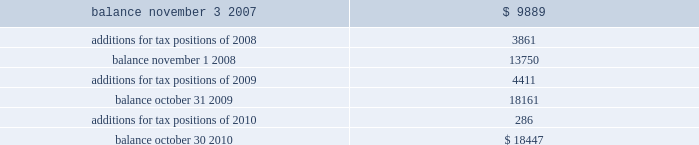Of global business , there are many transactions and calculations where the ultimate tax outcome is uncertain .
Some of these uncertainties arise as a consequence of cost reimbursement arrangements among related entities .
Although the company believes its estimates are reasonable , no assurance can be given that the final tax outcome of these matters will not be different than that which is reflected in the historical income tax provisions and accruals .
Such differences could have a material impact on the company 2019s income tax provision and operating results in the period in which such determination is made .
On november 4 , 2007 ( the first day of its 2008 fiscal year ) , the company adopted new accounting principles on accounting for uncertain tax positions .
These principles require companies to determine whether it is 201cmore likely than not 201d that a tax position will be sustained upon examination by the appropriate taxing authorities before any benefit can be recorded in the financial statements .
An uncertain income tax position will not be recognized if it has less than a 50% ( 50 % ) likelihood of being sustained .
There were no changes to the company 2019s liabilities for uncertain tax positions as a result of the adoption of these provisions .
As of october 30 , 2010 and october 31 , 2009 , the company had a liability of $ 18.4 million and $ 18.2 million , respectively , for gross unrealized tax benefits , all of which , if settled in the company 2019s favor , would lower the company 2019s effective tax rate in the period recorded .
In addition , as of october 30 , 2010 and october 31 , 2009 , the company had a liability of approximately $ 9.8 million and $ 8.0 million , respectively , for interest and penalties .
The total liability as of october 30 , 2010 and october 31 , 2009 of $ 28.3 million and $ 26.2 million , respectively , for uncertain tax positions is classified as non-current , and is included in other non-current liabilities , because the company believes that the ultimate payment or settlement of these liabilities will not occur within the next twelve months .
Prior to the adoption of these provisions , these amounts were included in current income tax payable .
The company includes interest and penalties related to unrecognized tax benefits within the provision for taxes in the condensed consolidated statements of income , and as a result , no change in classification was made upon adopting these provisions .
The condensed consolidated statements of income for fiscal years 2010 , 2009 and 2008 include $ 1.8 million , $ 1.7 million and $ 1.3 million , respectively , of interest and penalties related to these uncertain tax positions .
Due to the complexity associated with its tax uncertainties , the company cannot make a reasonably reliable estimate as to the period in which it expects to settle the liabilities associated with these uncertain tax positions .
The table summarizes the changes in the total amounts of uncertain tax positions for fiscal 2008 through fiscal 2010. .
Fiscal years 2004 and 2005 irs examination during the fourth quarter of fiscal 2007 , the irs completed its field examination of the company 2019s fiscal years 2004 and 2005 .
On january 2 , 2008 , the irs issued its report for fiscal 2004 and 2005 , which included proposed adjustments related to these two fiscal years .
The company has recorded taxes and penalties related to certain of these proposed adjustments .
There are four items with an additional potential total tax liability of $ 46 million .
The company has concluded , based on discussions with its tax advisors , that these four items are not likely to result in any additional tax liability .
Therefore , the company has not recorded any additional tax liability for these items and is appealing these proposed adjustments through the normal processes for the resolution of differences between the irs and taxpayers .
The company 2019s initial meetings with the appellate division of the irs were held during fiscal analog devices , inc .
Notes to consolidated financial statements 2014 ( continued ) .
What was the percentage increase of income for the fiscal years of 2008 to 2010? 
Rationale: to find the percentage increase of income for the years of 2008 to 2010 one must subtract these two years from each other and then divide the answer by the income for 2008 .
Computations: ((1.8 - 1.3) / 1.3)
Answer: 0.38462. 